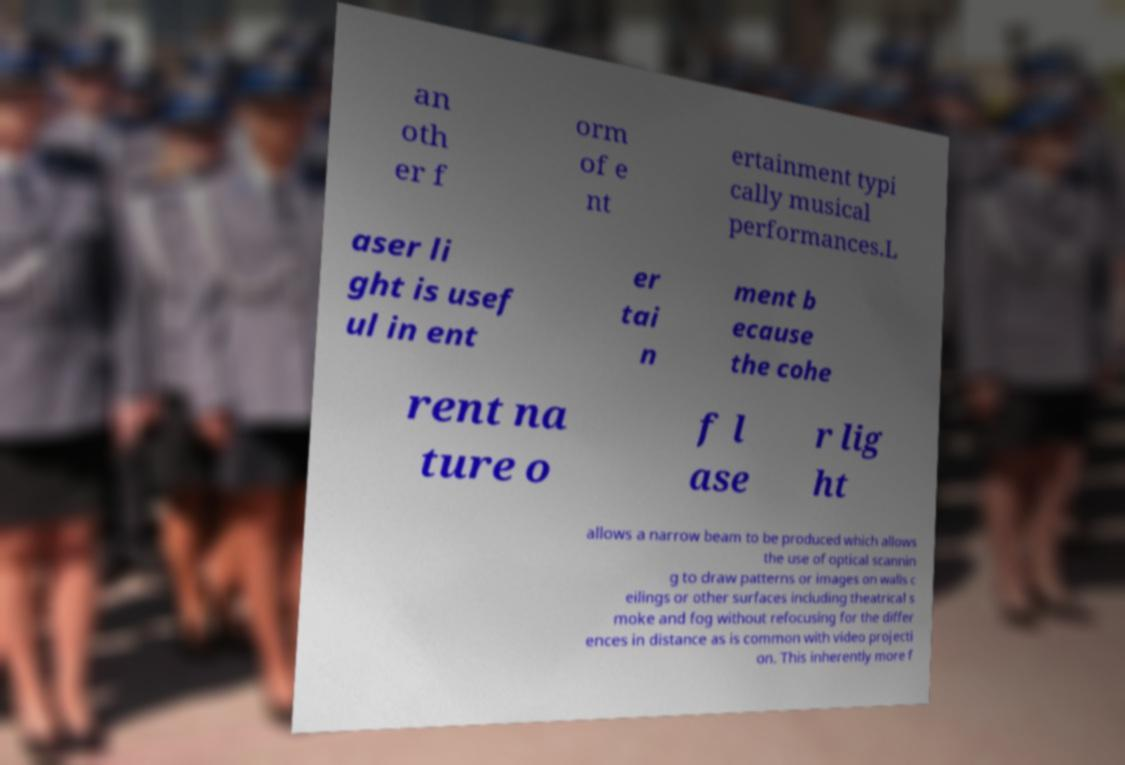For documentation purposes, I need the text within this image transcribed. Could you provide that? an oth er f orm of e nt ertainment typi cally musical performances.L aser li ght is usef ul in ent er tai n ment b ecause the cohe rent na ture o f l ase r lig ht allows a narrow beam to be produced which allows the use of optical scannin g to draw patterns or images on walls c eilings or other surfaces including theatrical s moke and fog without refocusing for the differ ences in distance as is common with video projecti on. This inherently more f 